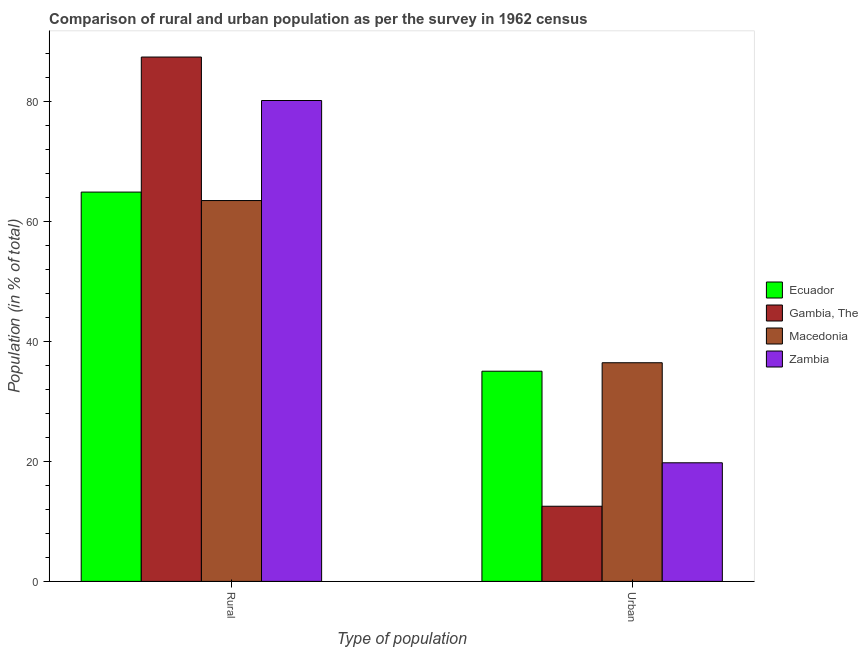Are the number of bars on each tick of the X-axis equal?
Your answer should be very brief. Yes. How many bars are there on the 2nd tick from the left?
Offer a very short reply. 4. How many bars are there on the 1st tick from the right?
Your answer should be very brief. 4. What is the label of the 2nd group of bars from the left?
Ensure brevity in your answer.  Urban. What is the rural population in Zambia?
Your answer should be very brief. 80.22. Across all countries, what is the maximum rural population?
Provide a short and direct response. 87.47. Across all countries, what is the minimum urban population?
Your answer should be very brief. 12.54. In which country was the rural population maximum?
Your answer should be compact. Gambia, The. In which country was the urban population minimum?
Provide a succinct answer. Gambia, The. What is the total rural population in the graph?
Offer a terse response. 296.15. What is the difference between the rural population in Macedonia and that in Zambia?
Keep it short and to the point. -16.69. What is the difference between the rural population in Macedonia and the urban population in Zambia?
Provide a short and direct response. 43.74. What is the average rural population per country?
Ensure brevity in your answer.  74.04. What is the difference between the rural population and urban population in Macedonia?
Offer a terse response. 27.05. In how many countries, is the urban population greater than 44 %?
Offer a terse response. 0. What is the ratio of the rural population in Gambia, The to that in Macedonia?
Your answer should be very brief. 1.38. Is the rural population in Ecuador less than that in Zambia?
Your answer should be very brief. Yes. What does the 2nd bar from the left in Urban represents?
Give a very brief answer. Gambia, The. What does the 4th bar from the right in Urban represents?
Provide a short and direct response. Ecuador. How many bars are there?
Offer a very short reply. 8. Are all the bars in the graph horizontal?
Provide a succinct answer. No. How many countries are there in the graph?
Your answer should be very brief. 4. What is the difference between two consecutive major ticks on the Y-axis?
Offer a terse response. 20. Are the values on the major ticks of Y-axis written in scientific E-notation?
Ensure brevity in your answer.  No. Does the graph contain grids?
Your response must be concise. No. What is the title of the graph?
Offer a very short reply. Comparison of rural and urban population as per the survey in 1962 census. Does "Upper middle income" appear as one of the legend labels in the graph?
Your response must be concise. No. What is the label or title of the X-axis?
Your response must be concise. Type of population. What is the label or title of the Y-axis?
Offer a terse response. Population (in % of total). What is the Population (in % of total) in Ecuador in Rural?
Make the answer very short. 64.94. What is the Population (in % of total) of Gambia, The in Rural?
Provide a succinct answer. 87.47. What is the Population (in % of total) in Macedonia in Rural?
Your answer should be compact. 63.53. What is the Population (in % of total) of Zambia in Rural?
Your response must be concise. 80.22. What is the Population (in % of total) of Ecuador in Urban?
Provide a short and direct response. 35.06. What is the Population (in % of total) of Gambia, The in Urban?
Make the answer very short. 12.54. What is the Population (in % of total) of Macedonia in Urban?
Offer a terse response. 36.47. What is the Population (in % of total) in Zambia in Urban?
Give a very brief answer. 19.79. Across all Type of population, what is the maximum Population (in % of total) in Ecuador?
Give a very brief answer. 64.94. Across all Type of population, what is the maximum Population (in % of total) of Gambia, The?
Your answer should be compact. 87.47. Across all Type of population, what is the maximum Population (in % of total) in Macedonia?
Your response must be concise. 63.53. Across all Type of population, what is the maximum Population (in % of total) in Zambia?
Keep it short and to the point. 80.22. Across all Type of population, what is the minimum Population (in % of total) of Ecuador?
Offer a very short reply. 35.06. Across all Type of population, what is the minimum Population (in % of total) in Gambia, The?
Your answer should be compact. 12.54. Across all Type of population, what is the minimum Population (in % of total) in Macedonia?
Provide a succinct answer. 36.47. Across all Type of population, what is the minimum Population (in % of total) in Zambia?
Your answer should be very brief. 19.79. What is the total Population (in % of total) of Gambia, The in the graph?
Give a very brief answer. 100. What is the total Population (in % of total) in Macedonia in the graph?
Make the answer very short. 100. What is the difference between the Population (in % of total) of Ecuador in Rural and that in Urban?
Your answer should be very brief. 29.88. What is the difference between the Population (in % of total) in Gambia, The in Rural and that in Urban?
Give a very brief answer. 74.93. What is the difference between the Population (in % of total) of Macedonia in Rural and that in Urban?
Provide a succinct answer. 27.05. What is the difference between the Population (in % of total) of Zambia in Rural and that in Urban?
Offer a very short reply. 60.43. What is the difference between the Population (in % of total) of Ecuador in Rural and the Population (in % of total) of Gambia, The in Urban?
Give a very brief answer. 52.41. What is the difference between the Population (in % of total) in Ecuador in Rural and the Population (in % of total) in Macedonia in Urban?
Offer a terse response. 28.47. What is the difference between the Population (in % of total) of Ecuador in Rural and the Population (in % of total) of Zambia in Urban?
Your response must be concise. 45.16. What is the difference between the Population (in % of total) of Gambia, The in Rural and the Population (in % of total) of Macedonia in Urban?
Offer a terse response. 50.99. What is the difference between the Population (in % of total) in Gambia, The in Rural and the Population (in % of total) in Zambia in Urban?
Your response must be concise. 67.68. What is the difference between the Population (in % of total) in Macedonia in Rural and the Population (in % of total) in Zambia in Urban?
Offer a very short reply. 43.74. What is the average Population (in % of total) of Ecuador per Type of population?
Make the answer very short. 50. What is the average Population (in % of total) in Gambia, The per Type of population?
Your answer should be compact. 50. What is the difference between the Population (in % of total) in Ecuador and Population (in % of total) in Gambia, The in Rural?
Keep it short and to the point. -22.52. What is the difference between the Population (in % of total) in Ecuador and Population (in % of total) in Macedonia in Rural?
Provide a short and direct response. 1.41. What is the difference between the Population (in % of total) in Ecuador and Population (in % of total) in Zambia in Rural?
Ensure brevity in your answer.  -15.28. What is the difference between the Population (in % of total) of Gambia, The and Population (in % of total) of Macedonia in Rural?
Give a very brief answer. 23.94. What is the difference between the Population (in % of total) in Gambia, The and Population (in % of total) in Zambia in Rural?
Provide a short and direct response. 7.25. What is the difference between the Population (in % of total) of Macedonia and Population (in % of total) of Zambia in Rural?
Provide a short and direct response. -16.69. What is the difference between the Population (in % of total) in Ecuador and Population (in % of total) in Gambia, The in Urban?
Keep it short and to the point. 22.52. What is the difference between the Population (in % of total) of Ecuador and Population (in % of total) of Macedonia in Urban?
Make the answer very short. -1.41. What is the difference between the Population (in % of total) in Ecuador and Population (in % of total) in Zambia in Urban?
Your answer should be very brief. 15.28. What is the difference between the Population (in % of total) of Gambia, The and Population (in % of total) of Macedonia in Urban?
Your response must be concise. -23.94. What is the difference between the Population (in % of total) of Gambia, The and Population (in % of total) of Zambia in Urban?
Provide a succinct answer. -7.25. What is the difference between the Population (in % of total) of Macedonia and Population (in % of total) of Zambia in Urban?
Provide a short and direct response. 16.69. What is the ratio of the Population (in % of total) in Ecuador in Rural to that in Urban?
Offer a terse response. 1.85. What is the ratio of the Population (in % of total) in Gambia, The in Rural to that in Urban?
Your response must be concise. 6.98. What is the ratio of the Population (in % of total) in Macedonia in Rural to that in Urban?
Provide a succinct answer. 1.74. What is the ratio of the Population (in % of total) in Zambia in Rural to that in Urban?
Your answer should be compact. 4.05. What is the difference between the highest and the second highest Population (in % of total) of Ecuador?
Your answer should be very brief. 29.88. What is the difference between the highest and the second highest Population (in % of total) in Gambia, The?
Make the answer very short. 74.93. What is the difference between the highest and the second highest Population (in % of total) in Macedonia?
Give a very brief answer. 27.05. What is the difference between the highest and the second highest Population (in % of total) in Zambia?
Offer a terse response. 60.43. What is the difference between the highest and the lowest Population (in % of total) of Ecuador?
Your answer should be compact. 29.88. What is the difference between the highest and the lowest Population (in % of total) in Gambia, The?
Provide a short and direct response. 74.93. What is the difference between the highest and the lowest Population (in % of total) of Macedonia?
Keep it short and to the point. 27.05. What is the difference between the highest and the lowest Population (in % of total) in Zambia?
Keep it short and to the point. 60.43. 